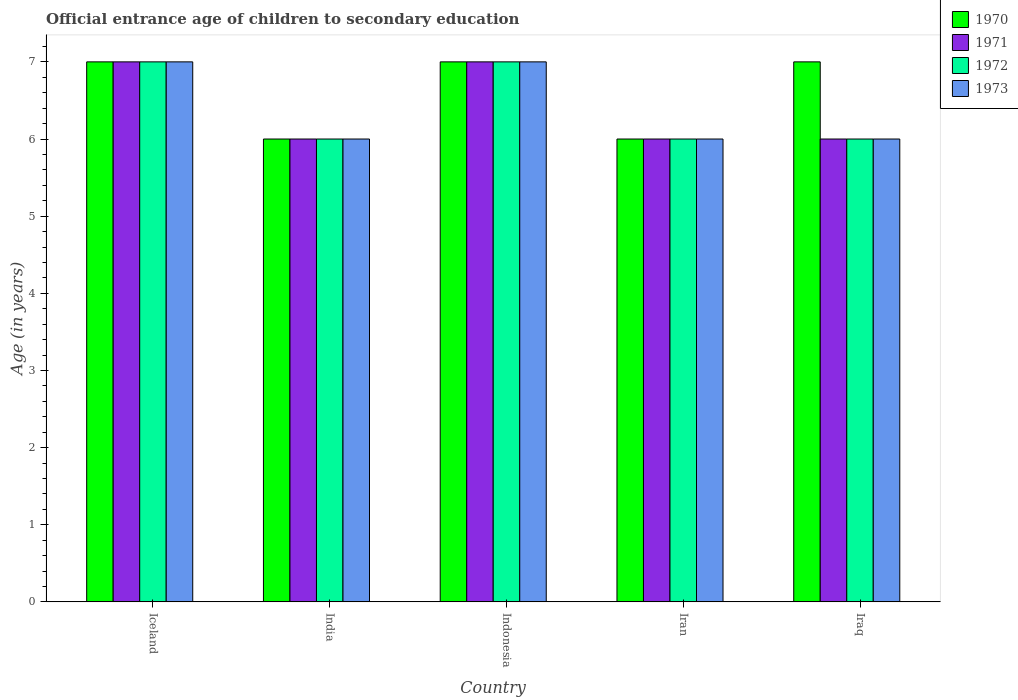How many different coloured bars are there?
Your answer should be very brief. 4. How many bars are there on the 3rd tick from the right?
Make the answer very short. 4. What is the label of the 2nd group of bars from the left?
Your answer should be compact. India. In how many cases, is the number of bars for a given country not equal to the number of legend labels?
Keep it short and to the point. 0. Across all countries, what is the maximum secondary school starting age of children in 1970?
Offer a very short reply. 7. Across all countries, what is the minimum secondary school starting age of children in 1973?
Make the answer very short. 6. In which country was the secondary school starting age of children in 1971 maximum?
Make the answer very short. Iceland. What is the average secondary school starting age of children in 1970 per country?
Provide a short and direct response. 6.6. What is the difference between the secondary school starting age of children of/in 1971 and secondary school starting age of children of/in 1970 in India?
Offer a terse response. 0. What is the ratio of the secondary school starting age of children in 1971 in India to that in Indonesia?
Your answer should be very brief. 0.86. What does the 4th bar from the left in Iceland represents?
Your answer should be compact. 1973. What does the 3rd bar from the right in Iceland represents?
Your answer should be very brief. 1971. Is it the case that in every country, the sum of the secondary school starting age of children in 1973 and secondary school starting age of children in 1970 is greater than the secondary school starting age of children in 1971?
Keep it short and to the point. Yes. How many bars are there?
Your answer should be compact. 20. What is the difference between two consecutive major ticks on the Y-axis?
Your response must be concise. 1. How are the legend labels stacked?
Keep it short and to the point. Vertical. What is the title of the graph?
Your answer should be compact. Official entrance age of children to secondary education. Does "1974" appear as one of the legend labels in the graph?
Ensure brevity in your answer.  No. What is the label or title of the Y-axis?
Keep it short and to the point. Age (in years). What is the Age (in years) of 1970 in Iceland?
Ensure brevity in your answer.  7. What is the Age (in years) of 1972 in Iceland?
Offer a terse response. 7. What is the Age (in years) in 1970 in India?
Your answer should be compact. 6. What is the Age (in years) of 1971 in India?
Make the answer very short. 6. What is the Age (in years) in 1972 in India?
Provide a succinct answer. 6. What is the Age (in years) of 1973 in India?
Make the answer very short. 6. What is the Age (in years) of 1972 in Indonesia?
Give a very brief answer. 7. What is the Age (in years) in 1973 in Indonesia?
Offer a very short reply. 7. What is the Age (in years) in 1970 in Iran?
Your response must be concise. 6. What is the Age (in years) in 1972 in Iran?
Offer a very short reply. 6. What is the Age (in years) in 1970 in Iraq?
Offer a terse response. 7. What is the Age (in years) in 1971 in Iraq?
Offer a very short reply. 6. What is the Age (in years) in 1972 in Iraq?
Your response must be concise. 6. What is the Age (in years) in 1973 in Iraq?
Offer a very short reply. 6. Across all countries, what is the maximum Age (in years) in 1971?
Your answer should be very brief. 7. Across all countries, what is the maximum Age (in years) in 1973?
Provide a succinct answer. 7. Across all countries, what is the minimum Age (in years) of 1970?
Keep it short and to the point. 6. Across all countries, what is the minimum Age (in years) in 1972?
Offer a very short reply. 6. What is the total Age (in years) of 1972 in the graph?
Keep it short and to the point. 32. What is the total Age (in years) in 1973 in the graph?
Provide a succinct answer. 32. What is the difference between the Age (in years) of 1971 in Iceland and that in India?
Make the answer very short. 1. What is the difference between the Age (in years) in 1973 in Iceland and that in India?
Your answer should be very brief. 1. What is the difference between the Age (in years) of 1970 in Iceland and that in Indonesia?
Make the answer very short. 0. What is the difference between the Age (in years) in 1971 in Iceland and that in Indonesia?
Offer a terse response. 0. What is the difference between the Age (in years) in 1972 in Iceland and that in Indonesia?
Make the answer very short. 0. What is the difference between the Age (in years) in 1973 in Iceland and that in Indonesia?
Keep it short and to the point. 0. What is the difference between the Age (in years) in 1970 in Iceland and that in Iran?
Ensure brevity in your answer.  1. What is the difference between the Age (in years) of 1972 in Iceland and that in Iran?
Provide a succinct answer. 1. What is the difference between the Age (in years) in 1973 in Iceland and that in Iran?
Ensure brevity in your answer.  1. What is the difference between the Age (in years) in 1970 in Iceland and that in Iraq?
Make the answer very short. 0. What is the difference between the Age (in years) of 1971 in India and that in Indonesia?
Offer a very short reply. -1. What is the difference between the Age (in years) of 1972 in India and that in Indonesia?
Offer a terse response. -1. What is the difference between the Age (in years) of 1973 in India and that in Indonesia?
Your response must be concise. -1. What is the difference between the Age (in years) in 1970 in India and that in Iran?
Provide a short and direct response. 0. What is the difference between the Age (in years) of 1971 in India and that in Iran?
Provide a succinct answer. 0. What is the difference between the Age (in years) of 1973 in India and that in Iran?
Offer a terse response. 0. What is the difference between the Age (in years) of 1971 in Indonesia and that in Iran?
Provide a succinct answer. 1. What is the difference between the Age (in years) in 1972 in Indonesia and that in Iran?
Give a very brief answer. 1. What is the difference between the Age (in years) in 1973 in Indonesia and that in Iran?
Make the answer very short. 1. What is the difference between the Age (in years) in 1970 in Iran and that in Iraq?
Offer a terse response. -1. What is the difference between the Age (in years) of 1971 in Iran and that in Iraq?
Provide a succinct answer. 0. What is the difference between the Age (in years) of 1970 in Iceland and the Age (in years) of 1972 in India?
Offer a very short reply. 1. What is the difference between the Age (in years) of 1970 in Iceland and the Age (in years) of 1973 in India?
Your answer should be compact. 1. What is the difference between the Age (in years) of 1971 in Iceland and the Age (in years) of 1972 in India?
Offer a very short reply. 1. What is the difference between the Age (in years) in 1972 in Iceland and the Age (in years) in 1973 in India?
Your response must be concise. 1. What is the difference between the Age (in years) in 1970 in Iceland and the Age (in years) in 1971 in Indonesia?
Your answer should be compact. 0. What is the difference between the Age (in years) in 1970 in Iceland and the Age (in years) in 1973 in Indonesia?
Your answer should be compact. 0. What is the difference between the Age (in years) of 1971 in Iceland and the Age (in years) of 1973 in Indonesia?
Your answer should be very brief. 0. What is the difference between the Age (in years) in 1972 in Iceland and the Age (in years) in 1973 in Indonesia?
Your answer should be compact. 0. What is the difference between the Age (in years) in 1970 in Iceland and the Age (in years) in 1972 in Iran?
Provide a short and direct response. 1. What is the difference between the Age (in years) of 1970 in Iceland and the Age (in years) of 1973 in Iran?
Provide a succinct answer. 1. What is the difference between the Age (in years) in 1970 in Iceland and the Age (in years) in 1971 in Iraq?
Offer a terse response. 1. What is the difference between the Age (in years) of 1971 in Iceland and the Age (in years) of 1972 in Iraq?
Offer a terse response. 1. What is the difference between the Age (in years) of 1971 in Iceland and the Age (in years) of 1973 in Iraq?
Give a very brief answer. 1. What is the difference between the Age (in years) in 1971 in India and the Age (in years) in 1972 in Indonesia?
Offer a terse response. -1. What is the difference between the Age (in years) in 1971 in India and the Age (in years) in 1973 in Indonesia?
Provide a short and direct response. -1. What is the difference between the Age (in years) of 1970 in India and the Age (in years) of 1971 in Iran?
Provide a short and direct response. 0. What is the difference between the Age (in years) in 1970 in India and the Age (in years) in 1972 in Iran?
Your response must be concise. 0. What is the difference between the Age (in years) in 1971 in India and the Age (in years) in 1972 in Iran?
Your answer should be very brief. 0. What is the difference between the Age (in years) of 1971 in India and the Age (in years) of 1973 in Iran?
Provide a short and direct response. 0. What is the difference between the Age (in years) of 1972 in India and the Age (in years) of 1973 in Iran?
Offer a very short reply. 0. What is the difference between the Age (in years) in 1970 in India and the Age (in years) in 1973 in Iraq?
Ensure brevity in your answer.  0. What is the difference between the Age (in years) of 1971 in India and the Age (in years) of 1972 in Iraq?
Provide a short and direct response. 0. What is the difference between the Age (in years) in 1971 in India and the Age (in years) in 1973 in Iraq?
Keep it short and to the point. 0. What is the difference between the Age (in years) of 1972 in India and the Age (in years) of 1973 in Iraq?
Your answer should be very brief. 0. What is the difference between the Age (in years) of 1970 in Indonesia and the Age (in years) of 1971 in Iran?
Offer a very short reply. 1. What is the difference between the Age (in years) in 1970 in Indonesia and the Age (in years) in 1973 in Iran?
Make the answer very short. 1. What is the difference between the Age (in years) in 1970 in Indonesia and the Age (in years) in 1971 in Iraq?
Your response must be concise. 1. What is the difference between the Age (in years) of 1970 in Indonesia and the Age (in years) of 1972 in Iraq?
Provide a succinct answer. 1. What is the difference between the Age (in years) of 1971 in Indonesia and the Age (in years) of 1972 in Iraq?
Offer a very short reply. 1. What is the difference between the Age (in years) in 1972 in Indonesia and the Age (in years) in 1973 in Iraq?
Offer a terse response. 1. What is the difference between the Age (in years) in 1970 in Iran and the Age (in years) in 1971 in Iraq?
Make the answer very short. 0. What is the difference between the Age (in years) of 1970 in Iran and the Age (in years) of 1973 in Iraq?
Ensure brevity in your answer.  0. What is the difference between the Age (in years) of 1971 in Iran and the Age (in years) of 1972 in Iraq?
Provide a succinct answer. 0. What is the average Age (in years) of 1972 per country?
Your answer should be very brief. 6.4. What is the difference between the Age (in years) in 1970 and Age (in years) in 1972 in Iceland?
Make the answer very short. 0. What is the difference between the Age (in years) of 1971 and Age (in years) of 1972 in Iceland?
Your answer should be very brief. 0. What is the difference between the Age (in years) in 1970 and Age (in years) in 1972 in India?
Make the answer very short. 0. What is the difference between the Age (in years) of 1970 and Age (in years) of 1973 in India?
Give a very brief answer. 0. What is the difference between the Age (in years) of 1971 and Age (in years) of 1972 in India?
Offer a terse response. 0. What is the difference between the Age (in years) of 1971 and Age (in years) of 1973 in India?
Ensure brevity in your answer.  0. What is the difference between the Age (in years) in 1970 and Age (in years) in 1971 in Indonesia?
Keep it short and to the point. 0. What is the difference between the Age (in years) in 1970 and Age (in years) in 1972 in Indonesia?
Offer a very short reply. 0. What is the difference between the Age (in years) in 1970 and Age (in years) in 1973 in Indonesia?
Ensure brevity in your answer.  0. What is the difference between the Age (in years) of 1970 and Age (in years) of 1972 in Iran?
Your answer should be compact. 0. What is the difference between the Age (in years) in 1970 and Age (in years) in 1973 in Iran?
Provide a succinct answer. 0. What is the difference between the Age (in years) in 1971 and Age (in years) in 1973 in Iran?
Make the answer very short. 0. What is the difference between the Age (in years) of 1970 and Age (in years) of 1971 in Iraq?
Provide a succinct answer. 1. What is the difference between the Age (in years) in 1972 and Age (in years) in 1973 in Iraq?
Your answer should be compact. 0. What is the ratio of the Age (in years) of 1970 in Iceland to that in India?
Your answer should be compact. 1.17. What is the ratio of the Age (in years) in 1971 in Iceland to that in India?
Offer a terse response. 1.17. What is the ratio of the Age (in years) in 1970 in Iceland to that in Indonesia?
Ensure brevity in your answer.  1. What is the ratio of the Age (in years) of 1972 in Iceland to that in Indonesia?
Provide a short and direct response. 1. What is the ratio of the Age (in years) of 1973 in Iceland to that in Indonesia?
Keep it short and to the point. 1. What is the ratio of the Age (in years) in 1971 in Iceland to that in Iran?
Ensure brevity in your answer.  1.17. What is the ratio of the Age (in years) in 1973 in Iceland to that in Iran?
Your response must be concise. 1.17. What is the ratio of the Age (in years) of 1971 in Iceland to that in Iraq?
Ensure brevity in your answer.  1.17. What is the ratio of the Age (in years) in 1971 in India to that in Indonesia?
Your answer should be very brief. 0.86. What is the ratio of the Age (in years) of 1973 in India to that in Indonesia?
Give a very brief answer. 0.86. What is the ratio of the Age (in years) in 1973 in India to that in Iran?
Provide a short and direct response. 1. What is the ratio of the Age (in years) of 1970 in India to that in Iraq?
Your answer should be very brief. 0.86. What is the ratio of the Age (in years) of 1973 in India to that in Iraq?
Your answer should be very brief. 1. What is the ratio of the Age (in years) of 1971 in Indonesia to that in Iran?
Give a very brief answer. 1.17. What is the ratio of the Age (in years) of 1972 in Indonesia to that in Iran?
Ensure brevity in your answer.  1.17. What is the ratio of the Age (in years) of 1972 in Indonesia to that in Iraq?
Keep it short and to the point. 1.17. What is the ratio of the Age (in years) in 1973 in Indonesia to that in Iraq?
Ensure brevity in your answer.  1.17. What is the ratio of the Age (in years) of 1970 in Iran to that in Iraq?
Your response must be concise. 0.86. What is the difference between the highest and the second highest Age (in years) in 1970?
Your answer should be compact. 0. What is the difference between the highest and the second highest Age (in years) of 1972?
Your answer should be very brief. 0. What is the difference between the highest and the lowest Age (in years) of 1970?
Provide a succinct answer. 1. What is the difference between the highest and the lowest Age (in years) in 1971?
Keep it short and to the point. 1. What is the difference between the highest and the lowest Age (in years) of 1972?
Make the answer very short. 1. 